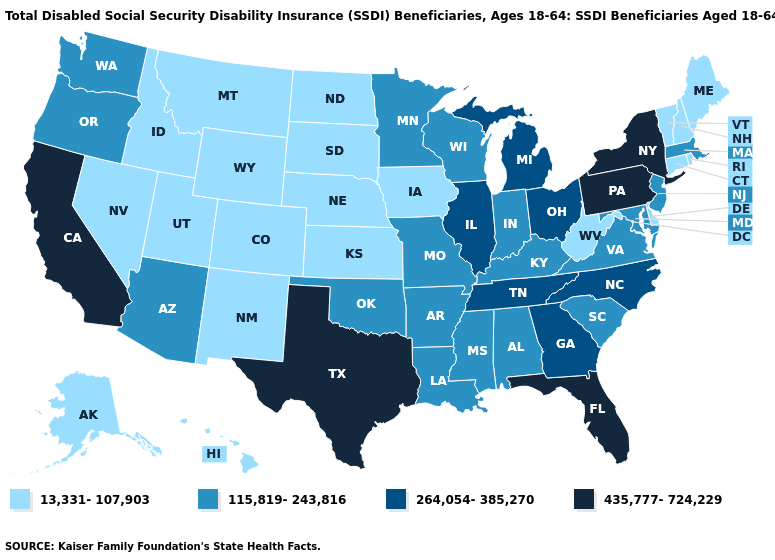What is the lowest value in the USA?
Write a very short answer. 13,331-107,903. What is the highest value in the USA?
Quick response, please. 435,777-724,229. What is the value of Nebraska?
Concise answer only. 13,331-107,903. Name the states that have a value in the range 264,054-385,270?
Be succinct. Georgia, Illinois, Michigan, North Carolina, Ohio, Tennessee. Name the states that have a value in the range 435,777-724,229?
Keep it brief. California, Florida, New York, Pennsylvania, Texas. What is the value of Indiana?
Short answer required. 115,819-243,816. Is the legend a continuous bar?
Concise answer only. No. What is the highest value in the USA?
Be succinct. 435,777-724,229. Name the states that have a value in the range 264,054-385,270?
Concise answer only. Georgia, Illinois, Michigan, North Carolina, Ohio, Tennessee. What is the value of Kentucky?
Concise answer only. 115,819-243,816. Does the map have missing data?
Write a very short answer. No. Does North Dakota have the highest value in the USA?
Be succinct. No. Name the states that have a value in the range 13,331-107,903?
Write a very short answer. Alaska, Colorado, Connecticut, Delaware, Hawaii, Idaho, Iowa, Kansas, Maine, Montana, Nebraska, Nevada, New Hampshire, New Mexico, North Dakota, Rhode Island, South Dakota, Utah, Vermont, West Virginia, Wyoming. Does South Dakota have a lower value than Maryland?
Keep it brief. Yes. Which states have the lowest value in the USA?
Answer briefly. Alaska, Colorado, Connecticut, Delaware, Hawaii, Idaho, Iowa, Kansas, Maine, Montana, Nebraska, Nevada, New Hampshire, New Mexico, North Dakota, Rhode Island, South Dakota, Utah, Vermont, West Virginia, Wyoming. 